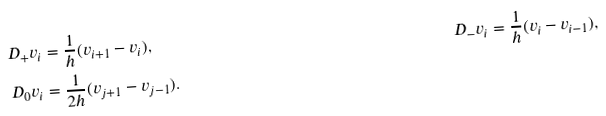<formula> <loc_0><loc_0><loc_500><loc_500>D _ { + } v _ { i } & = \frac { 1 } { h } ( v _ { i + 1 } - v _ { i } ) , \quad & D _ { - } v _ { i } = \frac { 1 } { h } ( v _ { i } - v _ { i - 1 } ) , \\ D _ { 0 } v _ { i } & = \frac { 1 } { 2 h } ( v _ { j + 1 } - v _ { j - 1 } ) . &</formula> 